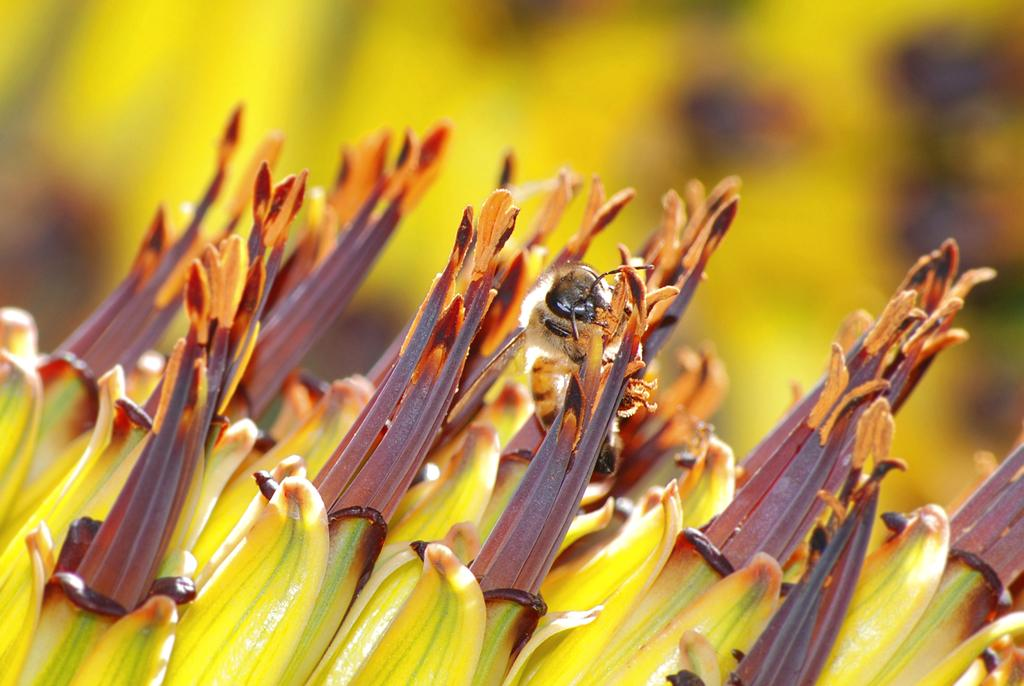What is the main subject of the image? There is an insect in the image. Where is the insect located? The insect is on a flower. Can you describe the background of the image? The background of the image is blurred. What type of plastic material can be seen surrounding the insect in the image? There is no plastic material surrounding the insect in the image; it is on a flower. Is the insect stuck in quicksand in the image? There is no quicksand present in the image, and the insect is on a flower. 